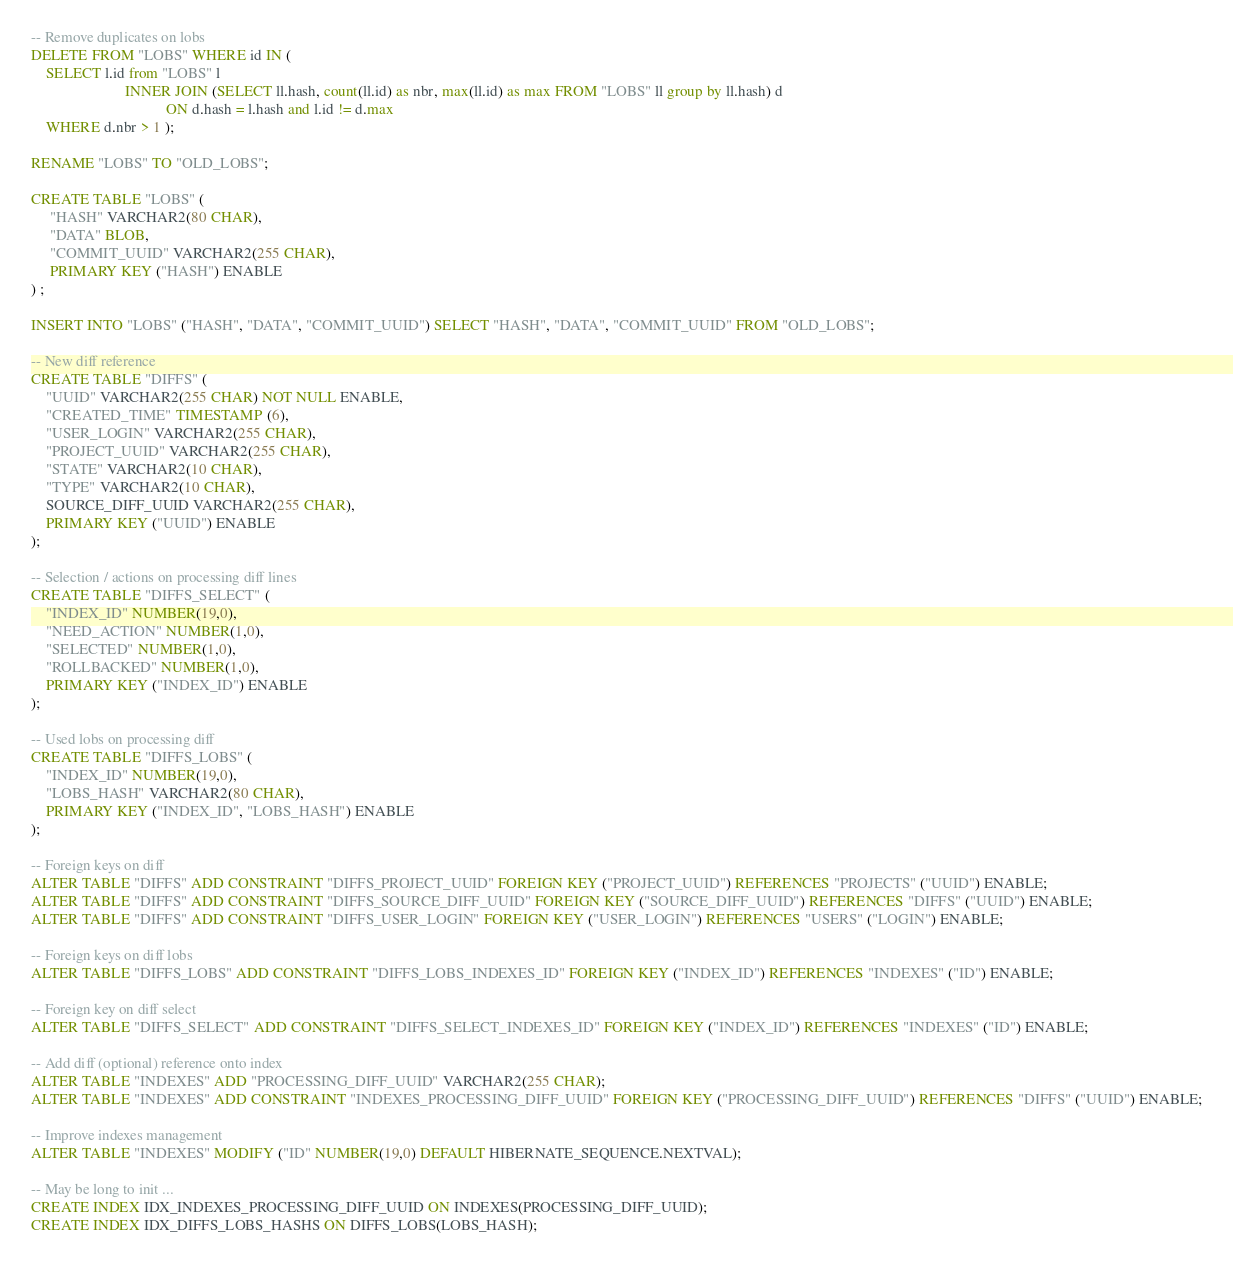<code> <loc_0><loc_0><loc_500><loc_500><_SQL_>-- Remove duplicates on lobs
DELETE FROM "LOBS" WHERE id IN (
    SELECT l.id from "LOBS" l
                         INNER JOIN (SELECT ll.hash, count(ll.id) as nbr, max(ll.id) as max FROM "LOBS" ll group by ll.hash) d
                                    ON d.hash = l.hash and l.id != d.max
    WHERE d.nbr > 1 );

RENAME "LOBS" TO "OLD_LOBS";

CREATE TABLE "LOBS" (
     "HASH" VARCHAR2(80 CHAR),
     "DATA" BLOB,
     "COMMIT_UUID" VARCHAR2(255 CHAR),
     PRIMARY KEY ("HASH") ENABLE
) ;

INSERT INTO "LOBS" ("HASH", "DATA", "COMMIT_UUID") SELECT "HASH", "DATA", "COMMIT_UUID" FROM "OLD_LOBS";

-- New diff reference
CREATE TABLE "DIFFS" (
    "UUID" VARCHAR2(255 CHAR) NOT NULL ENABLE,
    "CREATED_TIME" TIMESTAMP (6),
    "USER_LOGIN" VARCHAR2(255 CHAR),
    "PROJECT_UUID" VARCHAR2(255 CHAR),
    "STATE" VARCHAR2(10 CHAR),
    "TYPE" VARCHAR2(10 CHAR),
    SOURCE_DIFF_UUID VARCHAR2(255 CHAR),
    PRIMARY KEY ("UUID") ENABLE
);

-- Selection / actions on processing diff lines
CREATE TABLE "DIFFS_SELECT" (
    "INDEX_ID" NUMBER(19,0),
    "NEED_ACTION" NUMBER(1,0),
    "SELECTED" NUMBER(1,0),
    "ROLLBACKED" NUMBER(1,0),
    PRIMARY KEY ("INDEX_ID") ENABLE
);

-- Used lobs on processing diff
CREATE TABLE "DIFFS_LOBS" (
    "INDEX_ID" NUMBER(19,0),
    "LOBS_HASH" VARCHAR2(80 CHAR),
    PRIMARY KEY ("INDEX_ID", "LOBS_HASH") ENABLE
);

-- Foreign keys on diff
ALTER TABLE "DIFFS" ADD CONSTRAINT "DIFFS_PROJECT_UUID" FOREIGN KEY ("PROJECT_UUID") REFERENCES "PROJECTS" ("UUID") ENABLE;
ALTER TABLE "DIFFS" ADD CONSTRAINT "DIFFS_SOURCE_DIFF_UUID" FOREIGN KEY ("SOURCE_DIFF_UUID") REFERENCES "DIFFS" ("UUID") ENABLE;
ALTER TABLE "DIFFS" ADD CONSTRAINT "DIFFS_USER_LOGIN" FOREIGN KEY ("USER_LOGIN") REFERENCES "USERS" ("LOGIN") ENABLE;

-- Foreign keys on diff lobs
ALTER TABLE "DIFFS_LOBS" ADD CONSTRAINT "DIFFS_LOBS_INDEXES_ID" FOREIGN KEY ("INDEX_ID") REFERENCES "INDEXES" ("ID") ENABLE;

-- Foreign key on diff select
ALTER TABLE "DIFFS_SELECT" ADD CONSTRAINT "DIFFS_SELECT_INDEXES_ID" FOREIGN KEY ("INDEX_ID") REFERENCES "INDEXES" ("ID") ENABLE;

-- Add diff (optional) reference onto index
ALTER TABLE "INDEXES" ADD "PROCESSING_DIFF_UUID" VARCHAR2(255 CHAR);
ALTER TABLE "INDEXES" ADD CONSTRAINT "INDEXES_PROCESSING_DIFF_UUID" FOREIGN KEY ("PROCESSING_DIFF_UUID") REFERENCES "DIFFS" ("UUID") ENABLE;

-- Improve indexes management
ALTER TABLE "INDEXES" MODIFY ("ID" NUMBER(19,0) DEFAULT HIBERNATE_SEQUENCE.NEXTVAL);

-- May be long to init ...
CREATE INDEX IDX_INDEXES_PROCESSING_DIFF_UUID ON INDEXES(PROCESSING_DIFF_UUID);
CREATE INDEX IDX_DIFFS_LOBS_HASHS ON DIFFS_LOBS(LOBS_HASH);</code> 